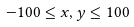Convert formula to latex. <formula><loc_0><loc_0><loc_500><loc_500>- 1 0 0 \leq x , y \leq 1 0 0</formula> 